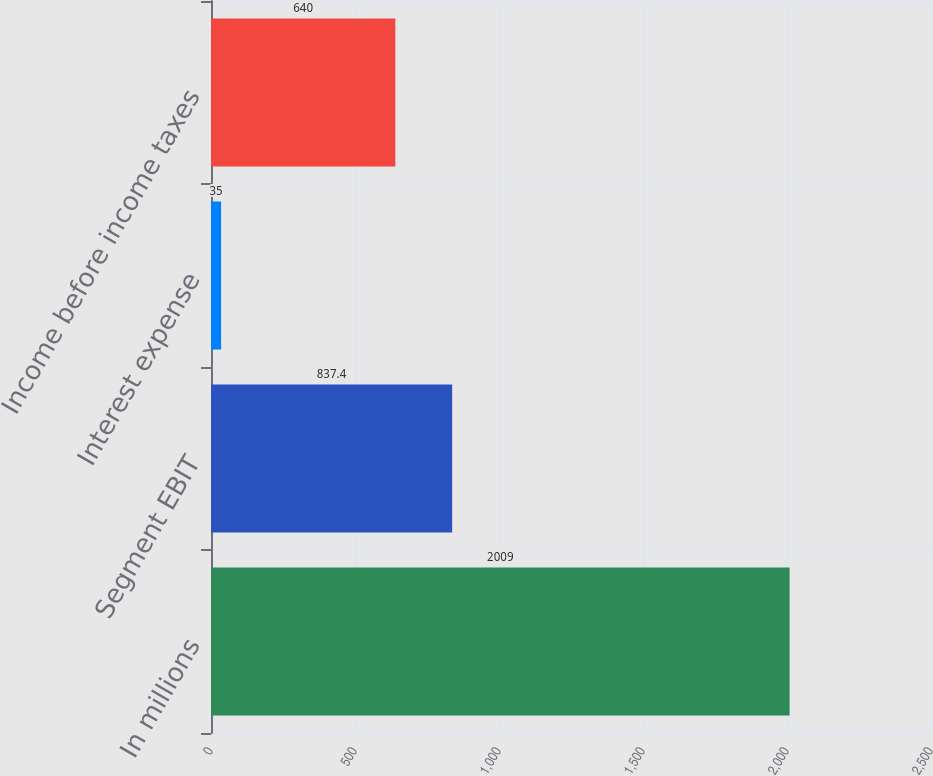Convert chart. <chart><loc_0><loc_0><loc_500><loc_500><bar_chart><fcel>In millions<fcel>Segment EBIT<fcel>Interest expense<fcel>Income before income taxes<nl><fcel>2009<fcel>837.4<fcel>35<fcel>640<nl></chart> 